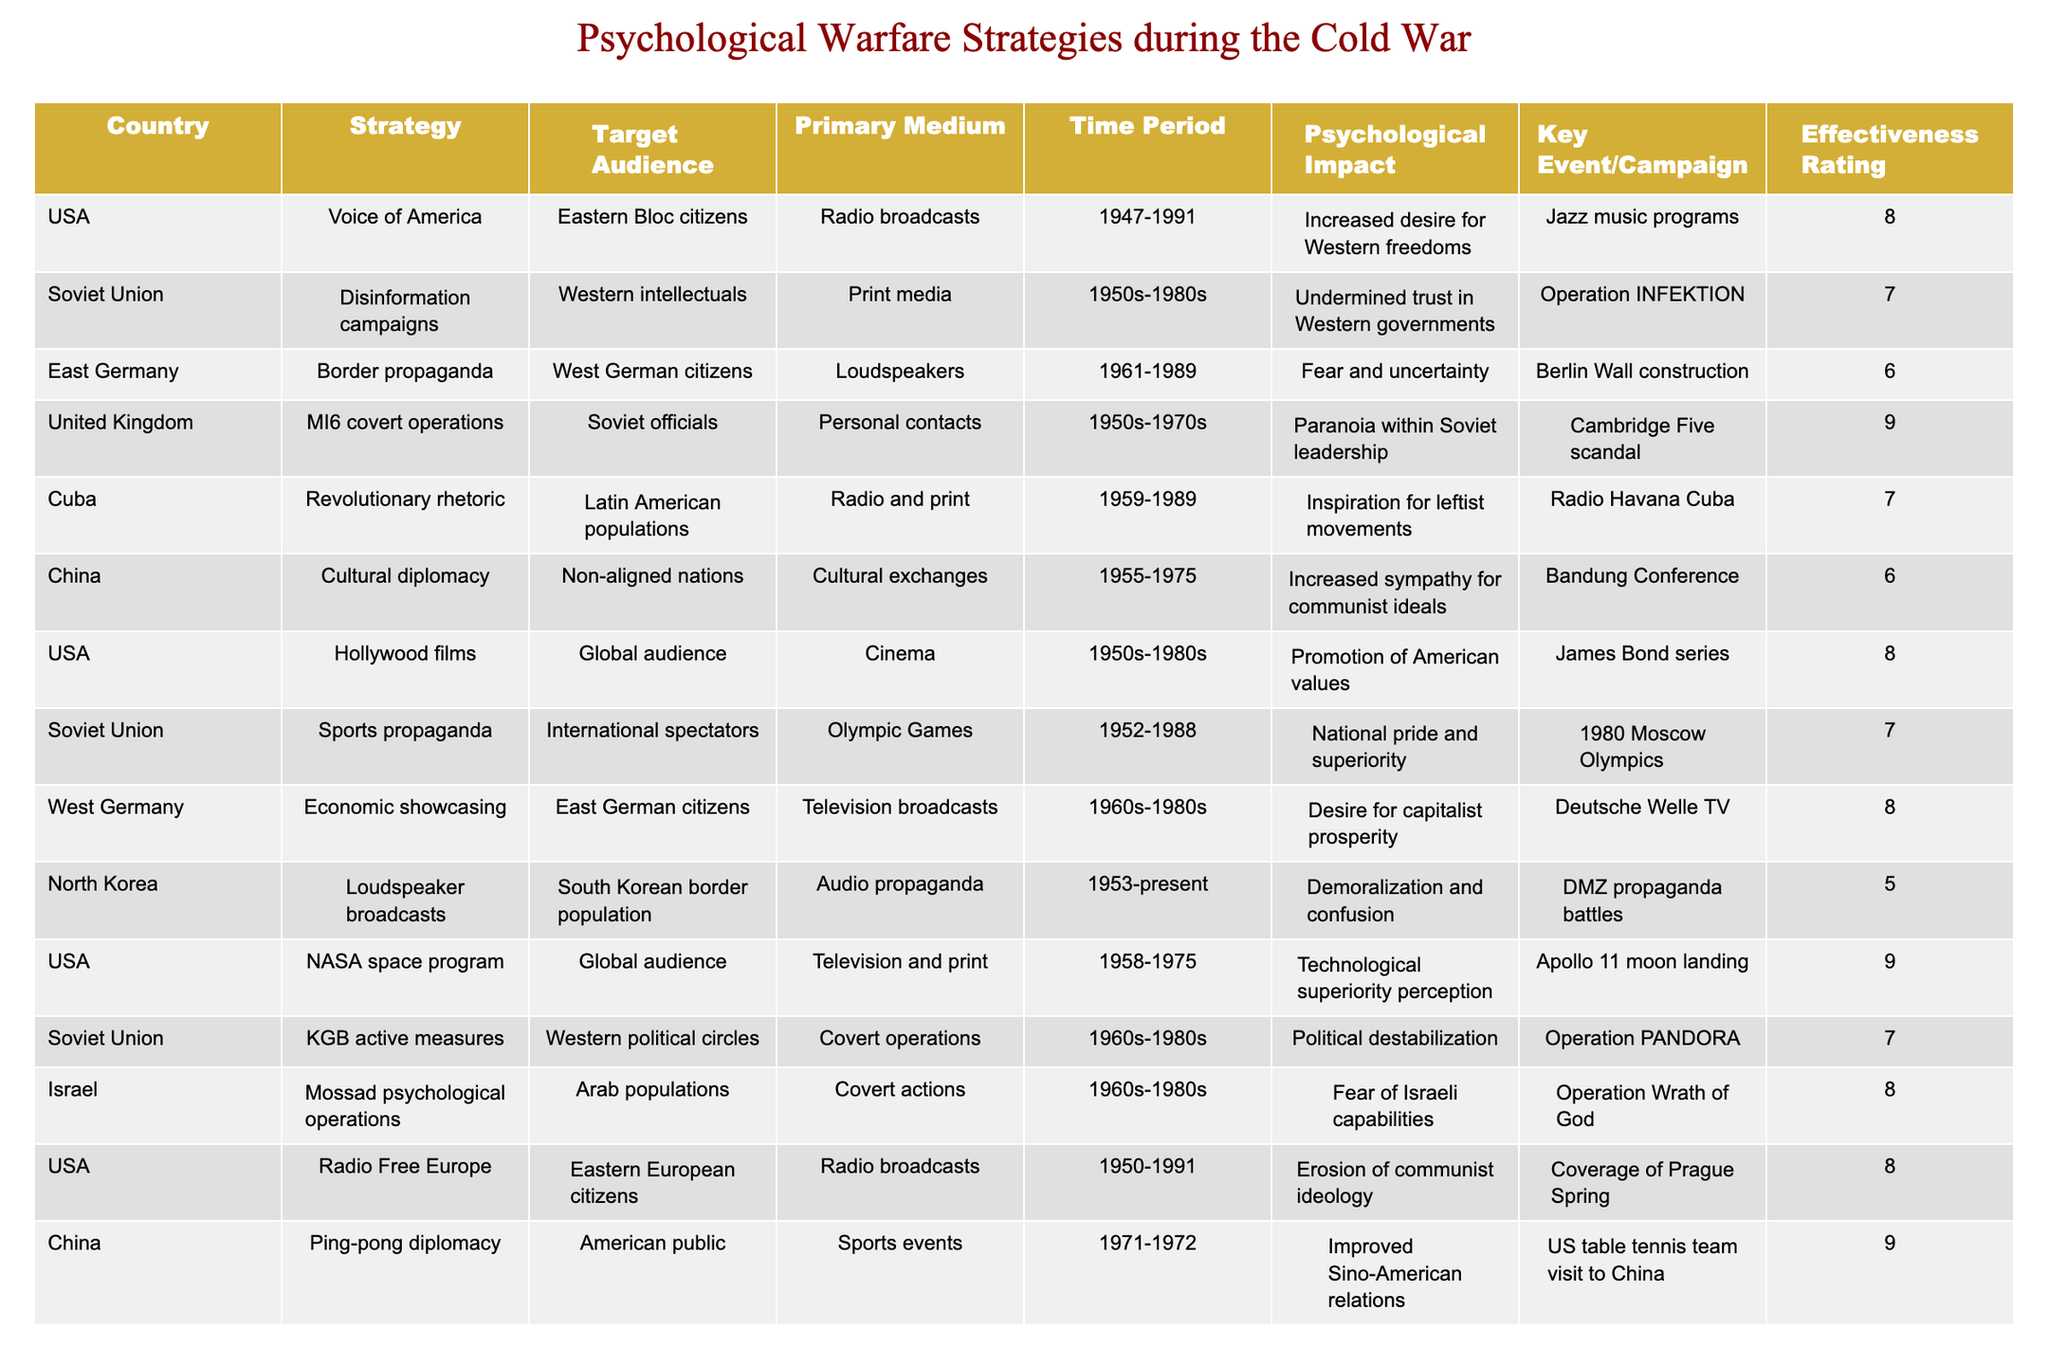What is the effectiveness rating of the strategy employed by the United Kingdom? Looking at the table, the United Kingdom's strategy, MI6 covert operations, has an effectiveness rating of 9.
Answer: 9 Which strategy had the highest effectiveness rating and what was it? By reviewing the effectiveness ratings in the table, the USA's NASA space program had the highest rating of 9.
Answer: NASA space program How many countries used radio broadcasts as a primary medium for their psychological warfare strategies? Referring to the table, the countries using radio broadcasts are the USA, Cuba, Radio Free Europe, and North Korea. That totals 4 countries.
Answer: 4 Which country employed cultural exchanges as a strategy, and what was its effectiveness rating? The table indicates that China used cultural diplomacy through cultural exchanges, with an effectiveness rating of 6.
Answer: China, 6 Is it true that all strategies with an effectiveness rating of 7 targeted Western intellectuals? Examining the table, not all strategies with a rating of 7 targeted Western intellectuals. The Soviet Union's disinformation campaigns did, but not the other strategies listed at that rating.
Answer: No What is the average effectiveness rating of strategies used by the USA? The USA employed three strategies with effectiveness ratings of 8 (Voice of America, Hollywood films), 9 (NASA space program), and 8 (Radio Free Europe). Therefore, the average is (8 + 9 + 8) / 3 = 8.33.
Answer: 8.33 Which country had the lowest effectiveness rating, and what was the strategy? Looking at the table, North Korea had the lowest effectiveness rating (5) with its strategy of loudspeaker broadcasts.
Answer: North Korea, loudspeaker broadcasts How many strategies were aimed at Latin American populations? The table shows that Cuba's Revolutionary rhetoric targeted Latin American populations as the only strategy. So the total is 1.
Answer: 1 What common medium was used by both the USA and Cuba in their strategies? Both the USA and Cuba utilized radio broadcasts as a primary medium for their strategies, as indicated in the table.
Answer: Radio broadcasts What percentage of the total strategies had an effectiveness rating of 8 or higher? The total number of strategies is 12. Those with ratings of 8 or higher are: USA (3), UK (1), Israel (1), and China (1), totaling 6. Thus, (6/12) * 100 = 50%.
Answer: 50% Which target audience was most commonly selected by these nations for their psychological warfare strategies? By inspecting the target audiences in the table, it appears that Eastern Bloc citizens were notably targeted by multiple strategies from the USA, which indicates a significant focus on this group.
Answer: Eastern Bloc citizens 